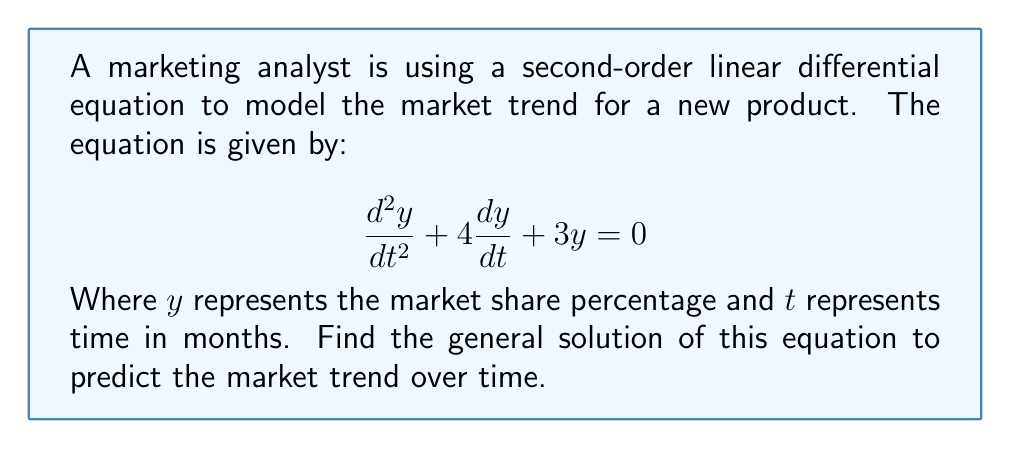What is the answer to this math problem? To solve this second-order linear homogeneous differential equation, we follow these steps:

1) First, we need to find the characteristic equation. For a second-order equation in the form $ay'' + by' + cy = 0$, the characteristic equation is $ar^2 + br + c = 0$.

   In this case, we have: $r^2 + 4r + 3 = 0$

2) We solve this quadratic equation:
   
   $r^2 + 4r + 3 = 0$
   $(r + 3)(r + 1) = 0$
   $r = -3$ or $r = -1$

3) Since we have two distinct real roots, the general solution will be in the form:

   $y = c_1e^{r_1t} + c_2e^{r_2t}$

   Where $c_1$ and $c_2$ are arbitrary constants, and $r_1$ and $r_2$ are the roots we found.

4) Substituting our roots:

   $y = c_1e^{-3t} + c_2e^{-t}$

This is the general solution to the differential equation. It represents the market share percentage as a function of time.

Interpreting this solution:
- The market share is a combination of two exponential decay terms.
- The $e^{-3t}$ term decays faster than the $e^{-t}$ term.
- Over time, both terms will approach zero, indicating that without additional factors, the market share for this product will eventually decline to zero.
- The constants $c_1$ and $c_2$ would be determined by initial conditions (e.g., initial market share and initial rate of change).
Answer: The general solution is:

$$y = c_1e^{-3t} + c_2e^{-t}$$

Where $c_1$ and $c_2$ are arbitrary constants, $y$ is the market share percentage, and $t$ is time in months. 